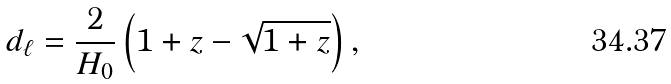<formula> <loc_0><loc_0><loc_500><loc_500>d _ { \ell } = \frac { 2 } { H _ { 0 } } \left ( 1 + z - \sqrt { 1 + z } \right ) ,</formula> 